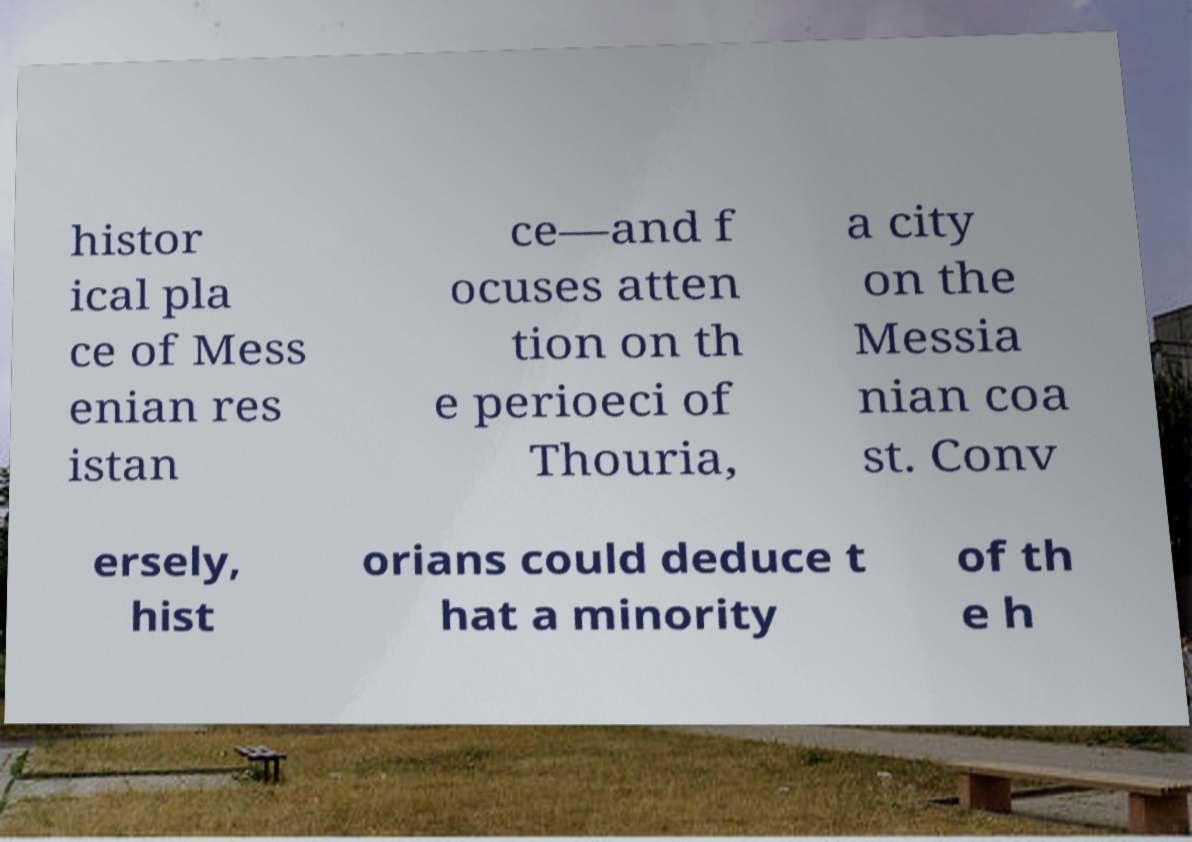There's text embedded in this image that I need extracted. Can you transcribe it verbatim? histor ical pla ce of Mess enian res istan ce—and f ocuses atten tion on th e perioeci of Thouria, a city on the Messia nian coa st. Conv ersely, hist orians could deduce t hat a minority of th e h 